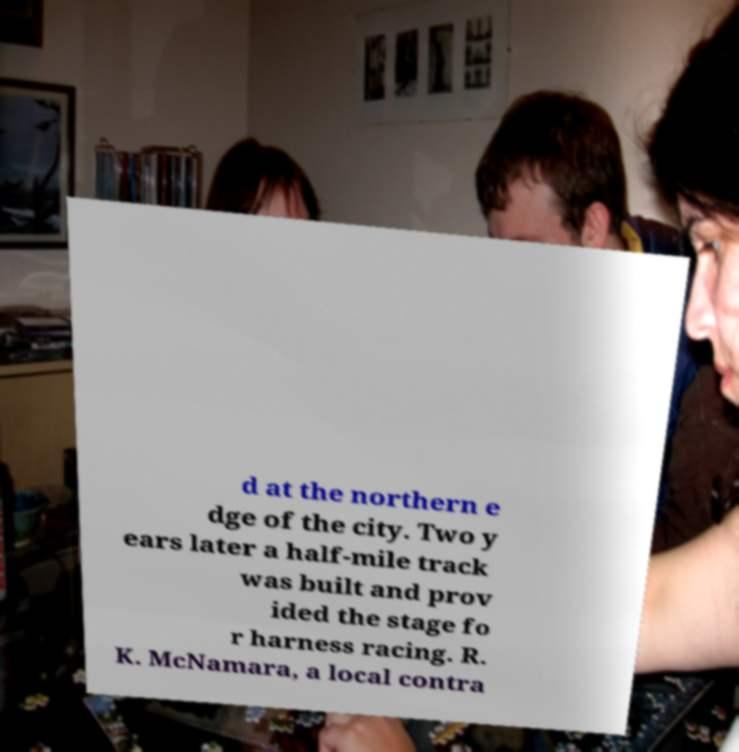What messages or text are displayed in this image? I need them in a readable, typed format. d at the northern e dge of the city. Two y ears later a half-mile track was built and prov ided the stage fo r harness racing. R. K. McNamara, a local contra 